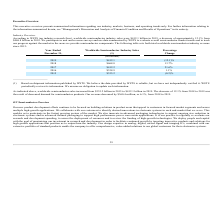According to On Semiconductor's financial document, How much was the worldwide semiconductor industry sales in 2019? According to the financial document, $412.1 billion. The relevant text states: "firm), worldwide semiconductor industry sales were $412.1 billion in 2019, a decrease of approximately 12.1% from $468.8 billion in 2018. We participate in unit and r..." Also, How much was the worldwide semiconductor industry sales in 2018? According to the financial document, $468.8 billion. The relevant text states: "on in 2019, a decrease of approximately 12.1% from $468.8 billion in 2018. We participate in unit and revenue surveys and use data summarized by WSTS to evaluate over..." Also, What led to the decrease of 12.1% semiconductor sales from 2018 to 2019? decreased demand for semiconductor products.. The document states: "rease of 12.1% from 2018 to 2019 was the result of decreased demand for semiconductor products. Our revenue decreased by $360.4 million, or 6.1%, from..." Also, can you calculate: What is the change in Worldwide Semiconductor Industry Sales from Year Ended December 31, 2018 to 2019? Based on the calculation: 412.1-468.8, the result is -56.7 (in billions). This is based on the information: "2019 $412.1 (12.1)% 2018 $468.8 13.7%..." The key data points involved are: 412.1, 468.8. Also, can you calculate: What is the change in Worldwide Semiconductor Industry Sales from Year Ended December 31, 2016 to 2017? Based on the calculation: 412.2-338.9, the result is 73.3 (in billions). This is based on the information: "2016 $338.9 1.1% 2017 $412.2 21.6%..." The key data points involved are: 338.9, 412.2. Also, can you calculate: What is the average Worldwide Semiconductor Industry Sales for Year Ended December 31, 2018 to 2019? To answer this question, I need to perform calculations using the financial data. The calculation is: (412.1+468.8) / 2, which equals 440.45 (in billions). This is based on the information: "2019 $412.1 (12.1)% 2018 $468.8 13.7%..." The key data points involved are: 412.1, 468.8. 